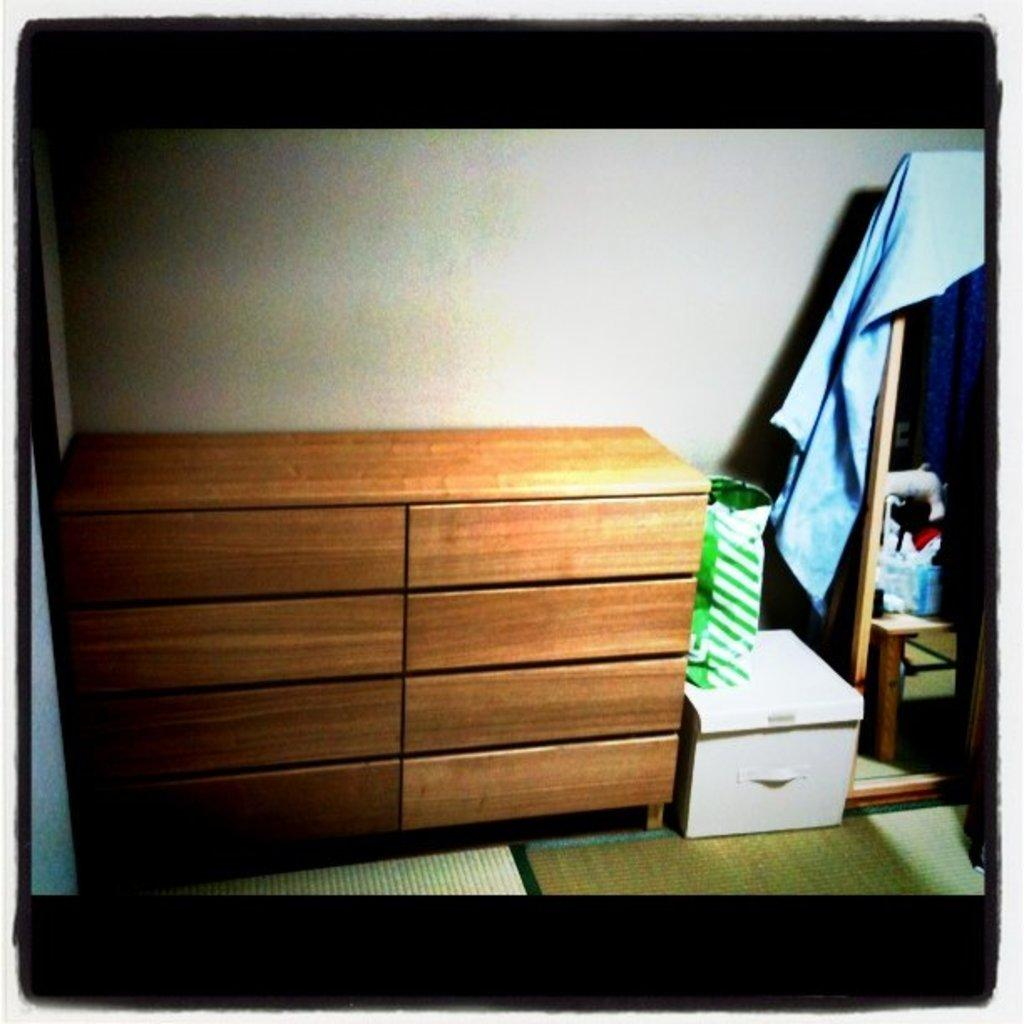What type of furniture is present in the image? There is a table with drawers in the image. What object is located beside the table? There is a small box beside the table. How is the small box covered? A cover is placed on the box. What can be seen hanging on a stand in the image? There is a cloth hanged on a stand in the image. What type of food is being prepared on the mountain in the image? There is no mountain or food preparation visible in the image. 